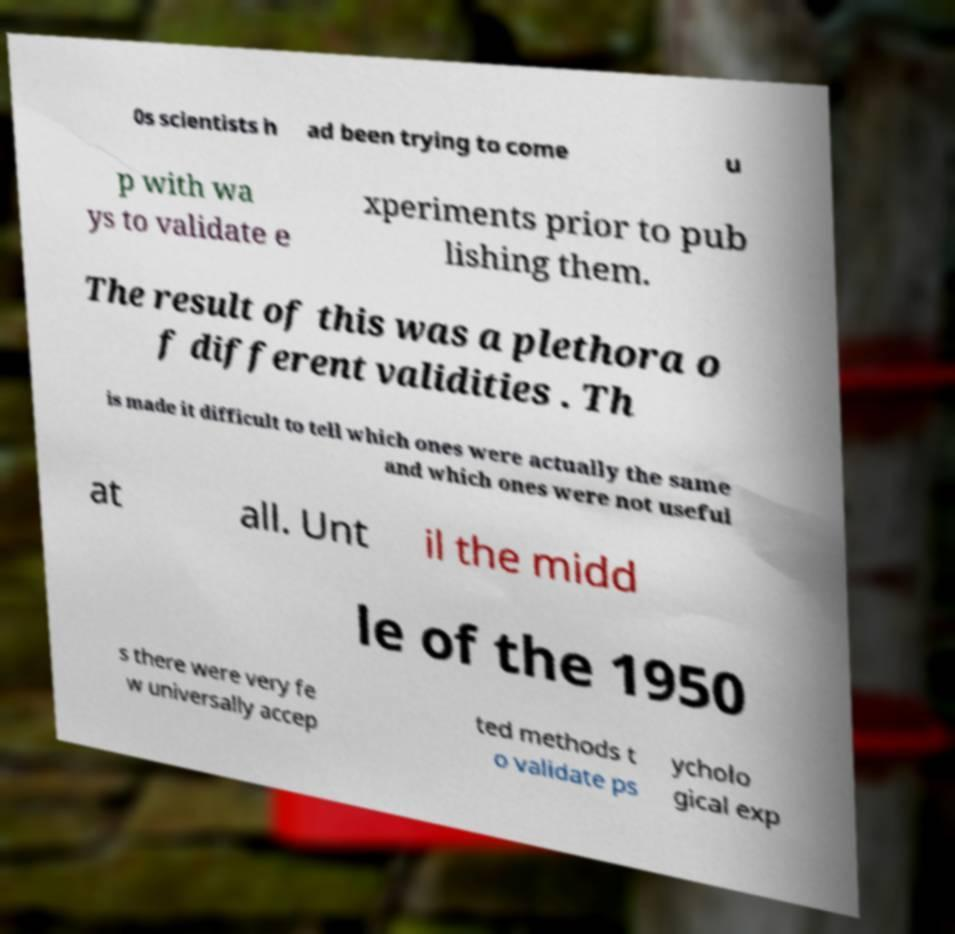What messages or text are displayed in this image? I need them in a readable, typed format. 0s scientists h ad been trying to come u p with wa ys to validate e xperiments prior to pub lishing them. The result of this was a plethora o f different validities . Th is made it difficult to tell which ones were actually the same and which ones were not useful at all. Unt il the midd le of the 1950 s there were very fe w universally accep ted methods t o validate ps ycholo gical exp 